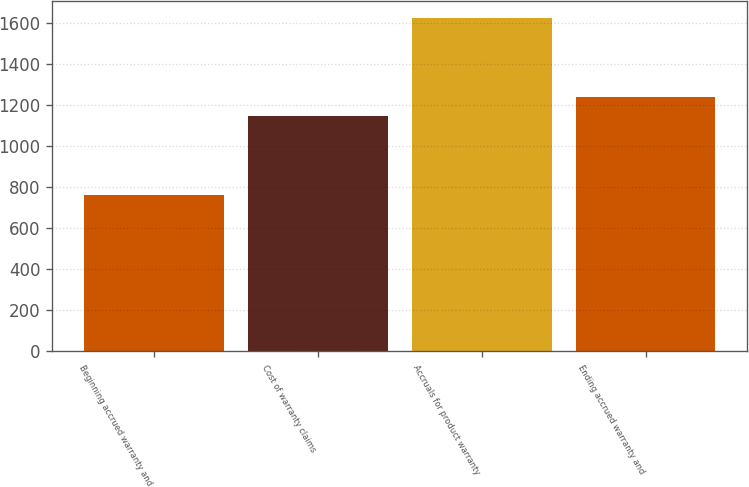<chart> <loc_0><loc_0><loc_500><loc_500><bar_chart><fcel>Beginning accrued warranty and<fcel>Cost of warranty claims<fcel>Accruals for product warranty<fcel>Ending accrued warranty and<nl><fcel>761<fcel>1147<fcel>1626<fcel>1240<nl></chart> 